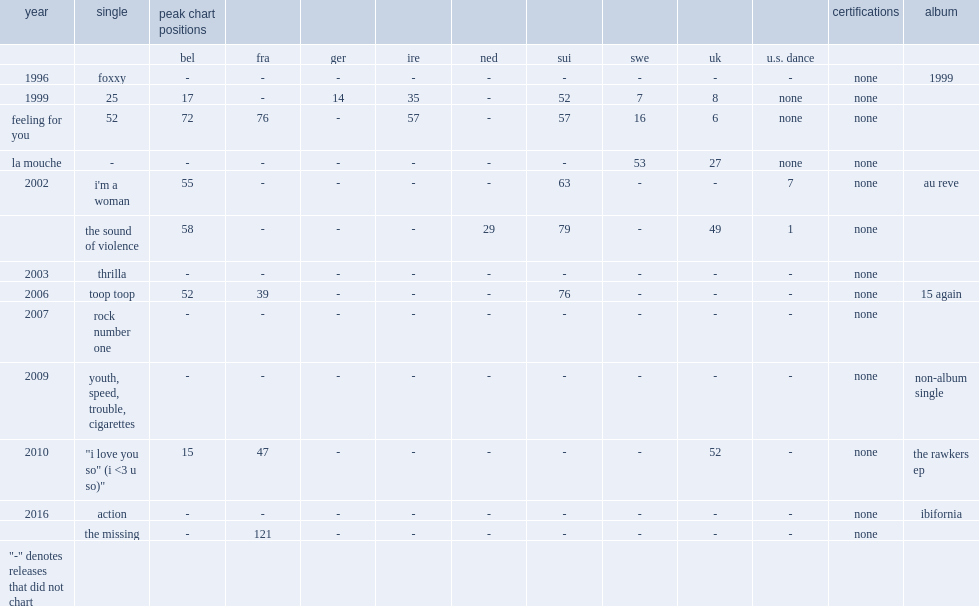In 2006, which album was cassius' single "toop toop" was featured on? 15 again. 